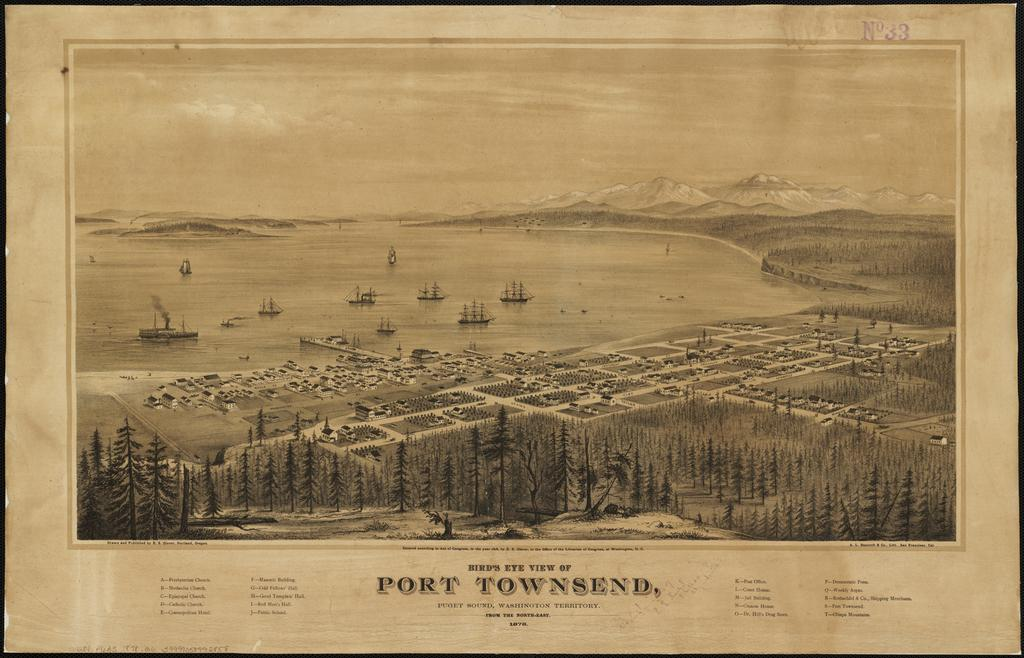<image>
Offer a succinct explanation of the picture presented. an old print of the town of Port Townsend 